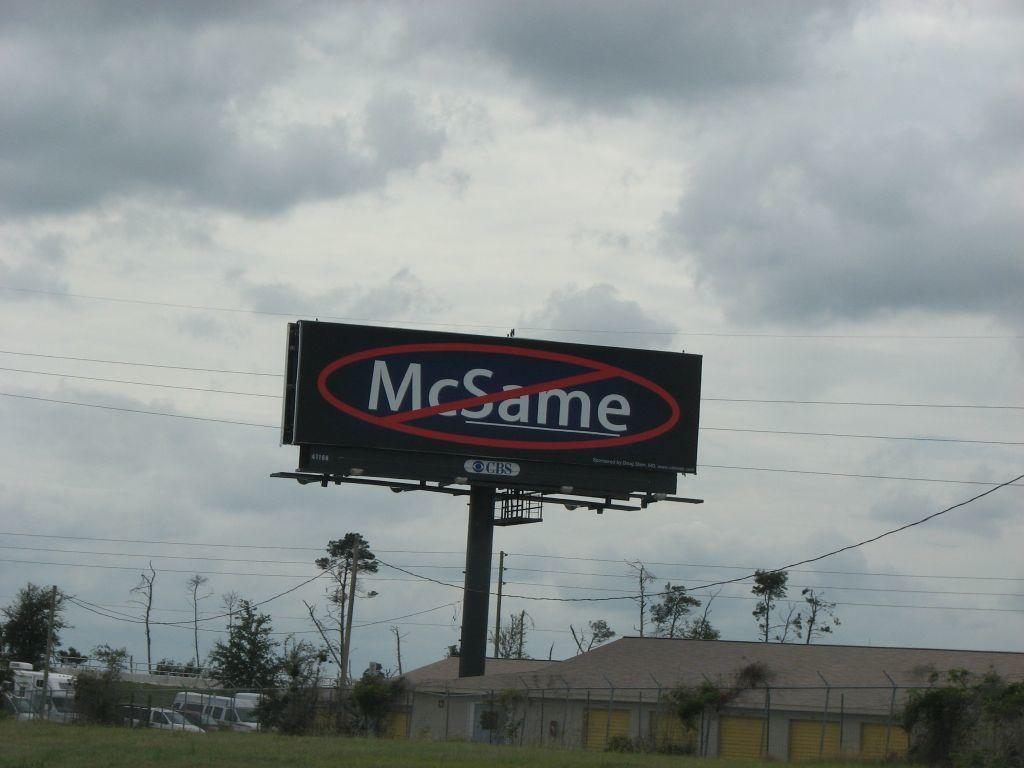<image>
Write a terse but informative summary of the picture. A tall black billboard which does not endorse McSame. 